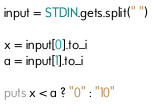Convert code to text. <code><loc_0><loc_0><loc_500><loc_500><_Ruby_>input = STDIN.gets.split(" ")

x = input[0].to_i
a = input[1].to_i

puts x < a ? "0" : "10"</code> 